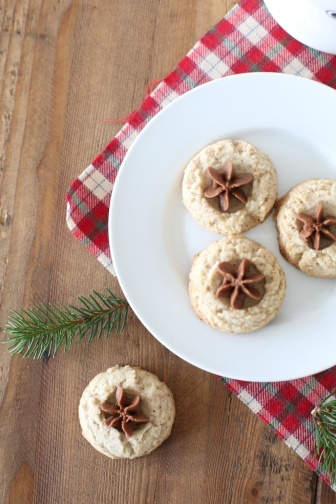What could be a creative recipe name for these cookies? Star-Kissed Holiday Harmony Cookies If these cookies had a magical property in a fantasy world, what would it be? In the enchanting realm of Eldoria, these 'Star-Kissed Holiday Harmony Cookies' are believed to possess the magical property of peace and unity. Once consumed, they impart a sense of calm and understanding, illuminating the hearts of those who partake in them with a radiant glow that fosters harmony and goodwill among all creatures. 